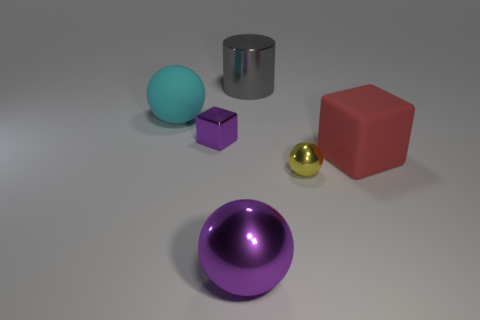Add 2 big red balls. How many objects exist? 8 Subtract all blocks. How many objects are left? 4 Add 3 small metal objects. How many small metal objects are left? 5 Add 5 tiny yellow objects. How many tiny yellow objects exist? 6 Subtract 0 blue blocks. How many objects are left? 6 Subtract all tiny purple blocks. Subtract all matte objects. How many objects are left? 3 